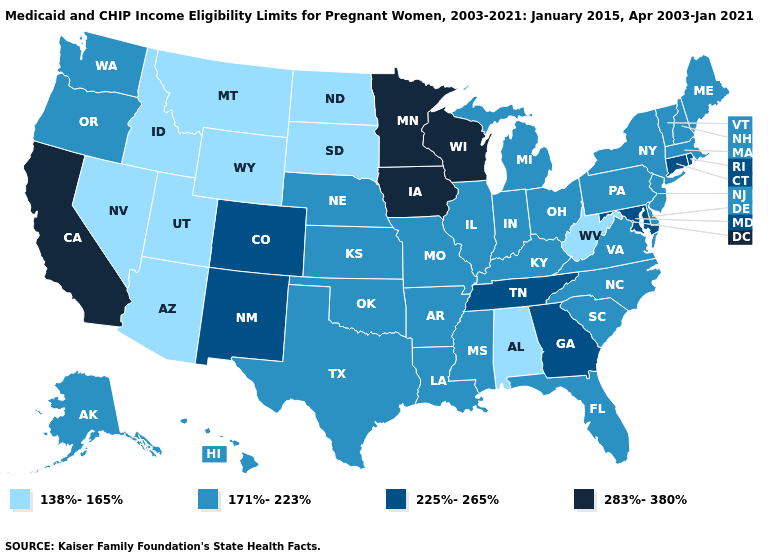Among the states that border Arizona , which have the highest value?
Give a very brief answer. California. What is the highest value in the USA?
Quick response, please. 283%-380%. Name the states that have a value in the range 138%-165%?
Concise answer only. Alabama, Arizona, Idaho, Montana, Nevada, North Dakota, South Dakota, Utah, West Virginia, Wyoming. Which states have the lowest value in the USA?
Short answer required. Alabama, Arizona, Idaho, Montana, Nevada, North Dakota, South Dakota, Utah, West Virginia, Wyoming. Name the states that have a value in the range 138%-165%?
Quick response, please. Alabama, Arizona, Idaho, Montana, Nevada, North Dakota, South Dakota, Utah, West Virginia, Wyoming. Name the states that have a value in the range 171%-223%?
Quick response, please. Alaska, Arkansas, Delaware, Florida, Hawaii, Illinois, Indiana, Kansas, Kentucky, Louisiana, Maine, Massachusetts, Michigan, Mississippi, Missouri, Nebraska, New Hampshire, New Jersey, New York, North Carolina, Ohio, Oklahoma, Oregon, Pennsylvania, South Carolina, Texas, Vermont, Virginia, Washington. What is the value of Oklahoma?
Keep it brief. 171%-223%. Does Michigan have a higher value than Kansas?
Keep it brief. No. Among the states that border Mississippi , does Alabama have the highest value?
Be succinct. No. What is the value of Georgia?
Write a very short answer. 225%-265%. Which states have the lowest value in the USA?
Give a very brief answer. Alabama, Arizona, Idaho, Montana, Nevada, North Dakota, South Dakota, Utah, West Virginia, Wyoming. Name the states that have a value in the range 225%-265%?
Short answer required. Colorado, Connecticut, Georgia, Maryland, New Mexico, Rhode Island, Tennessee. Does West Virginia have a lower value than Washington?
Keep it brief. Yes. What is the lowest value in the South?
Short answer required. 138%-165%. Which states have the highest value in the USA?
Keep it brief. California, Iowa, Minnesota, Wisconsin. 